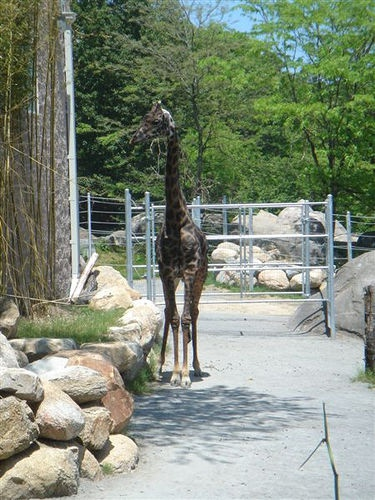Describe the objects in this image and their specific colors. I can see a giraffe in darkgreen, black, gray, lightgray, and darkgray tones in this image. 